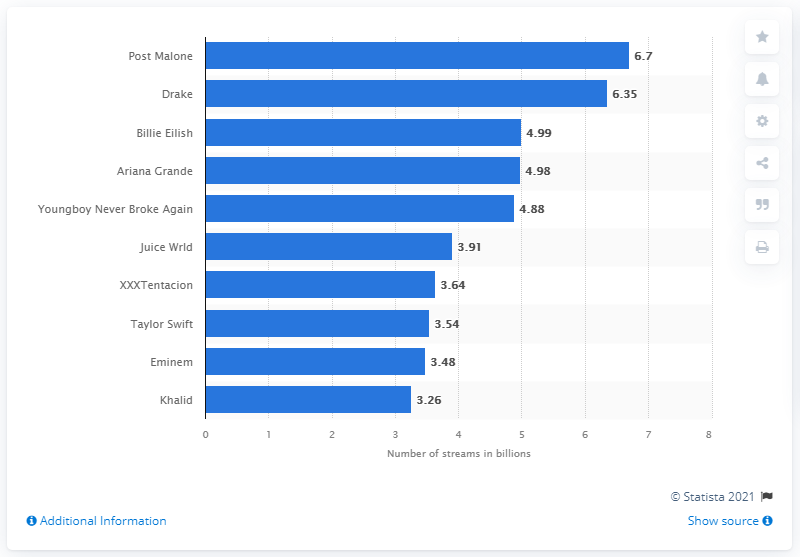Indicate a few pertinent items in this graphic. I. "Which hip-hop artist earned almost 6.7 billion streams in the U.S. in 2019?"
II. Post Malone is the hip-hop artist who earned almost 6.7 billion streams in the U.S. in 2019. In 2019, Drake came in second in streaming streams. 